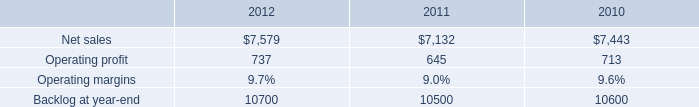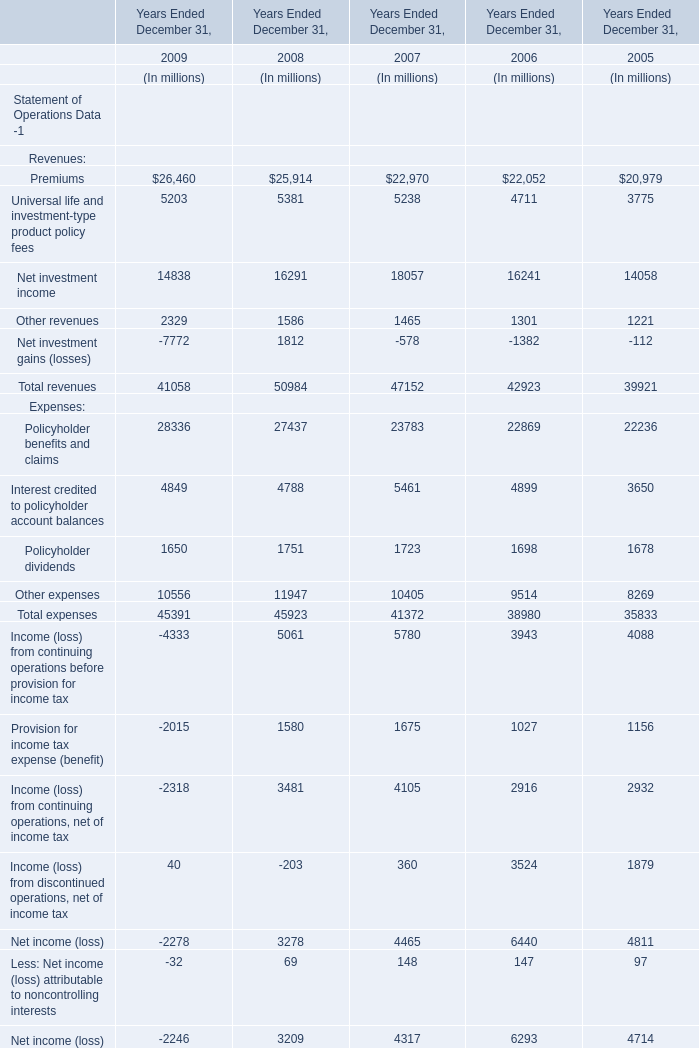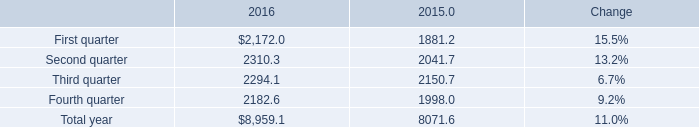What is the growing rate of Interest credited to policyholder account balances in the years with the least Policyholder benefits and claims? 
Computations: ((4899 - 3650) / 3650)
Answer: 0.34219. 